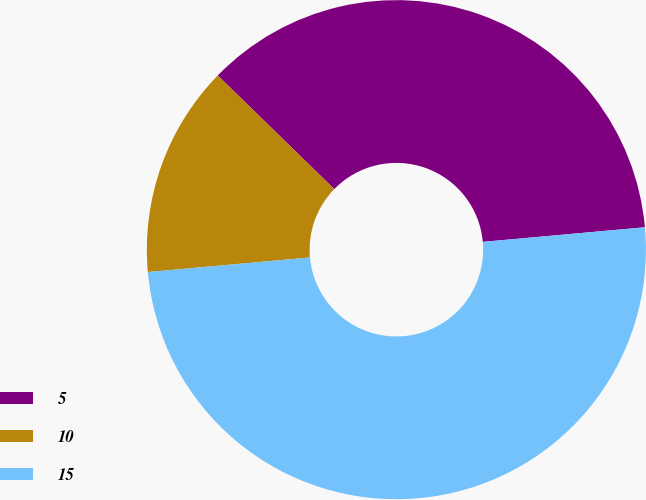Convert chart. <chart><loc_0><loc_0><loc_500><loc_500><pie_chart><fcel>5<fcel>10<fcel>15<nl><fcel>36.27%<fcel>13.73%<fcel>50.0%<nl></chart> 